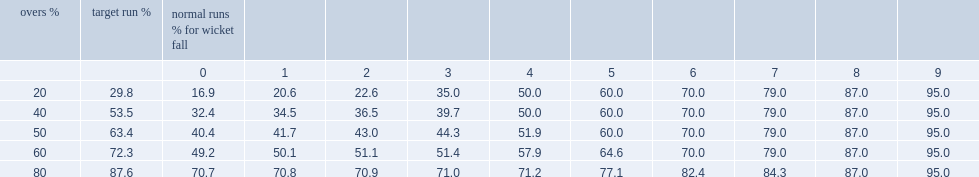What are the corresponding percentages for the "target run" and the "overs"? 87.6 80.0. 